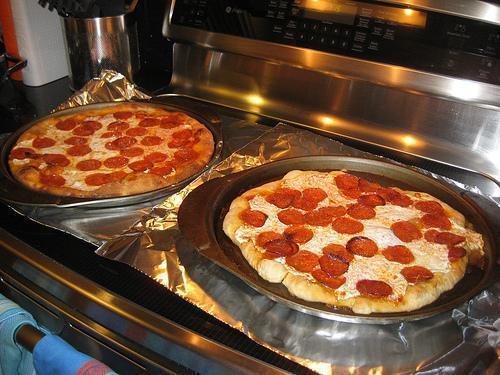How many pizzas are shown?
Give a very brief answer. 2. How many burned sousages are on the pizza on wright?
Give a very brief answer. 8. 